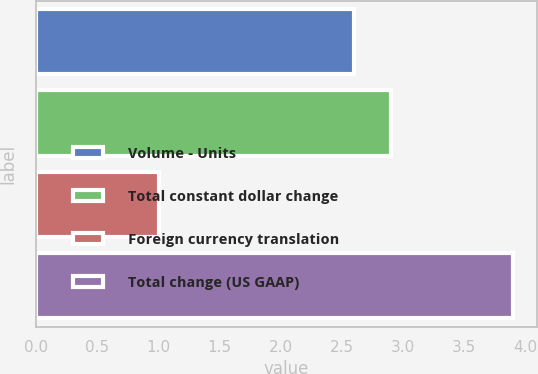Convert chart to OTSL. <chart><loc_0><loc_0><loc_500><loc_500><bar_chart><fcel>Volume - Units<fcel>Total constant dollar change<fcel>Foreign currency translation<fcel>Total change (US GAAP)<nl><fcel>2.6<fcel>2.9<fcel>1<fcel>3.9<nl></chart> 